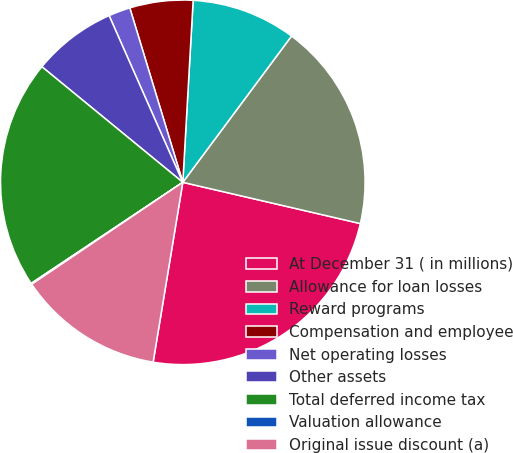<chart> <loc_0><loc_0><loc_500><loc_500><pie_chart><fcel>At December 31 ( in millions)<fcel>Allowance for loan losses<fcel>Reward programs<fcel>Compensation and employee<fcel>Net operating losses<fcel>Other assets<fcel>Total deferred income tax<fcel>Valuation allowance<fcel>Original issue discount (a)<nl><fcel>23.97%<fcel>18.46%<fcel>9.27%<fcel>5.6%<fcel>1.93%<fcel>7.44%<fcel>20.29%<fcel>0.09%<fcel>12.95%<nl></chart> 